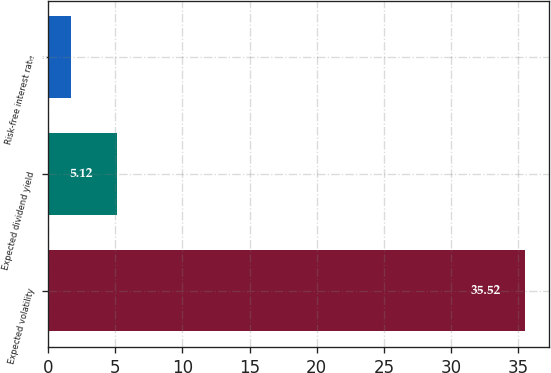Convert chart. <chart><loc_0><loc_0><loc_500><loc_500><bar_chart><fcel>Expected volatility<fcel>Expected dividend yield<fcel>Risk-free interest rate<nl><fcel>35.52<fcel>5.12<fcel>1.74<nl></chart> 